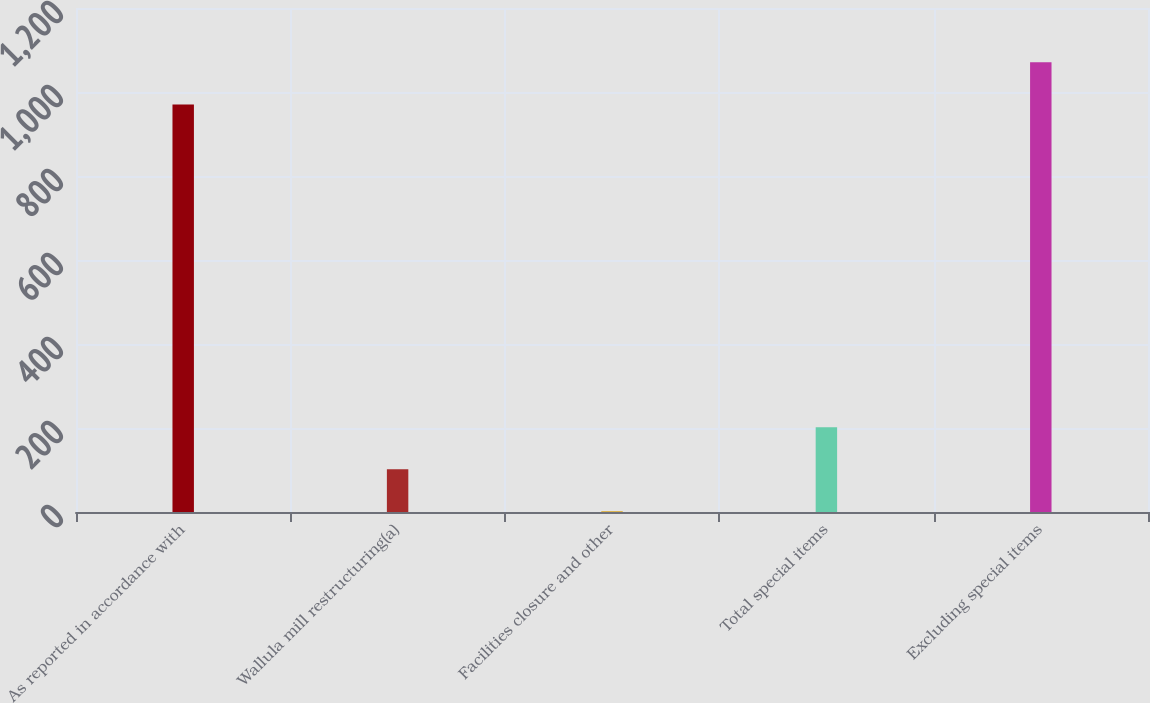Convert chart to OTSL. <chart><loc_0><loc_0><loc_500><loc_500><bar_chart><fcel>As reported in accordance with<fcel>Wallula mill restructuring(a)<fcel>Facilities closure and other<fcel>Total special items<fcel>Excluding special items<nl><fcel>970.5<fcel>101.92<fcel>1.8<fcel>202.04<fcel>1070.62<nl></chart> 